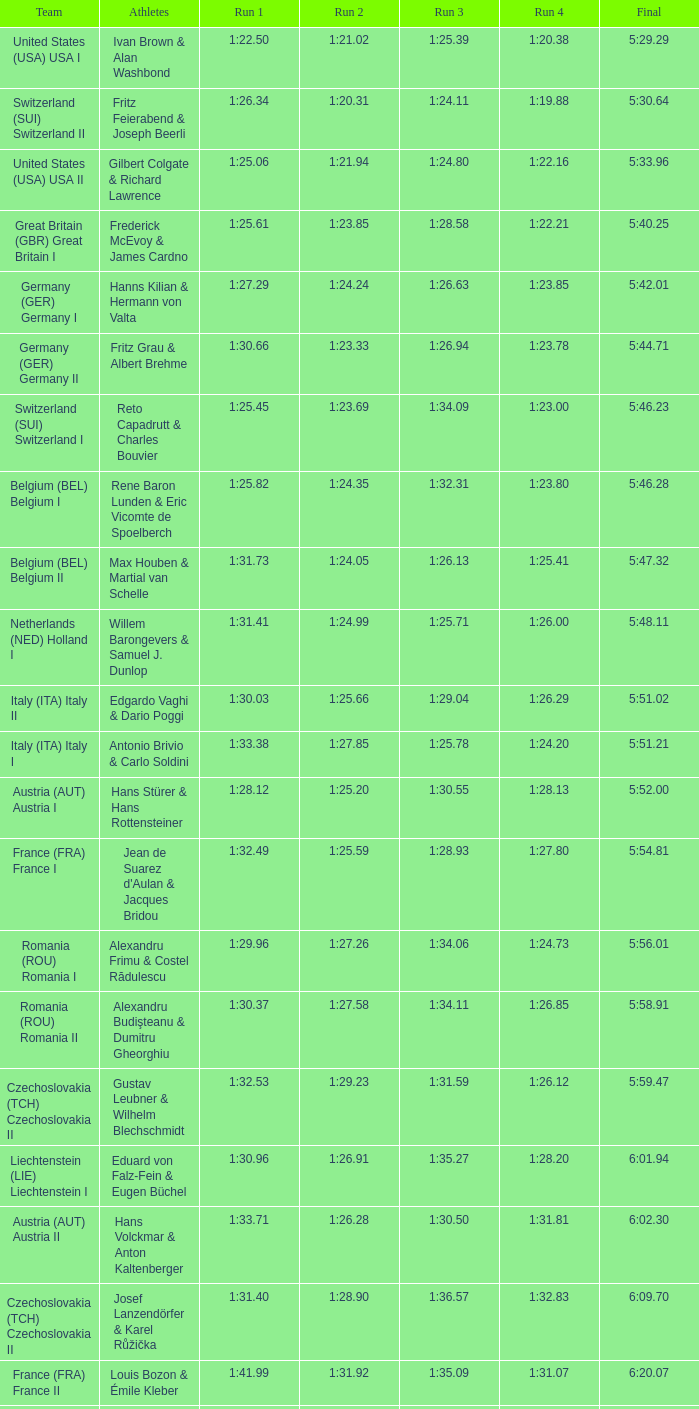Which run 2 corresponds to a run 1 time of 1:30.03? 1:25.66. 